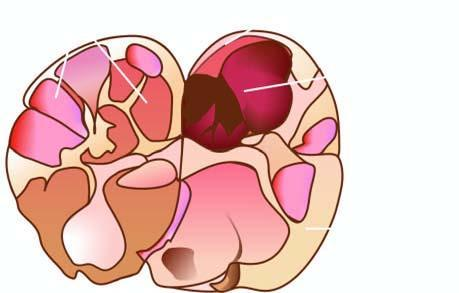does the epidermis show a solitary nodule having capsule?
Answer the question using a single word or phrase. No 